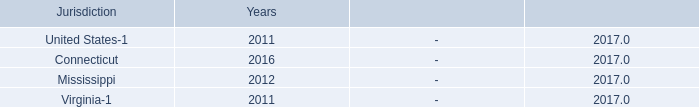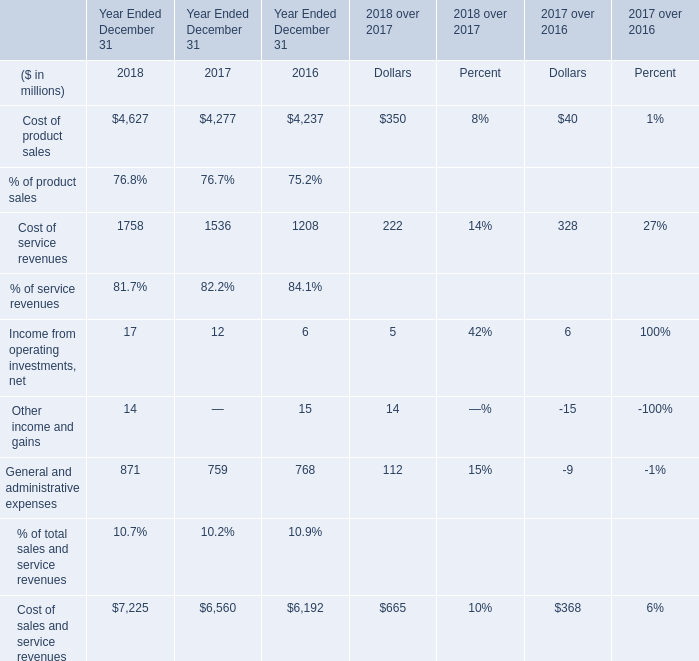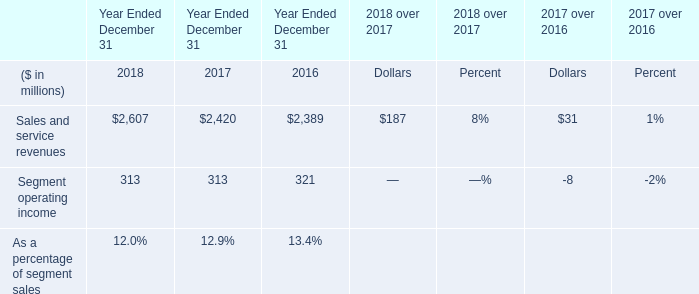what is the liability for interest and penalties as of december 31 , 2017? 
Computations: (1 - 1)
Answer: 0.0. 